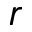Convert formula to latex. <formula><loc_0><loc_0><loc_500><loc_500>r</formula> 